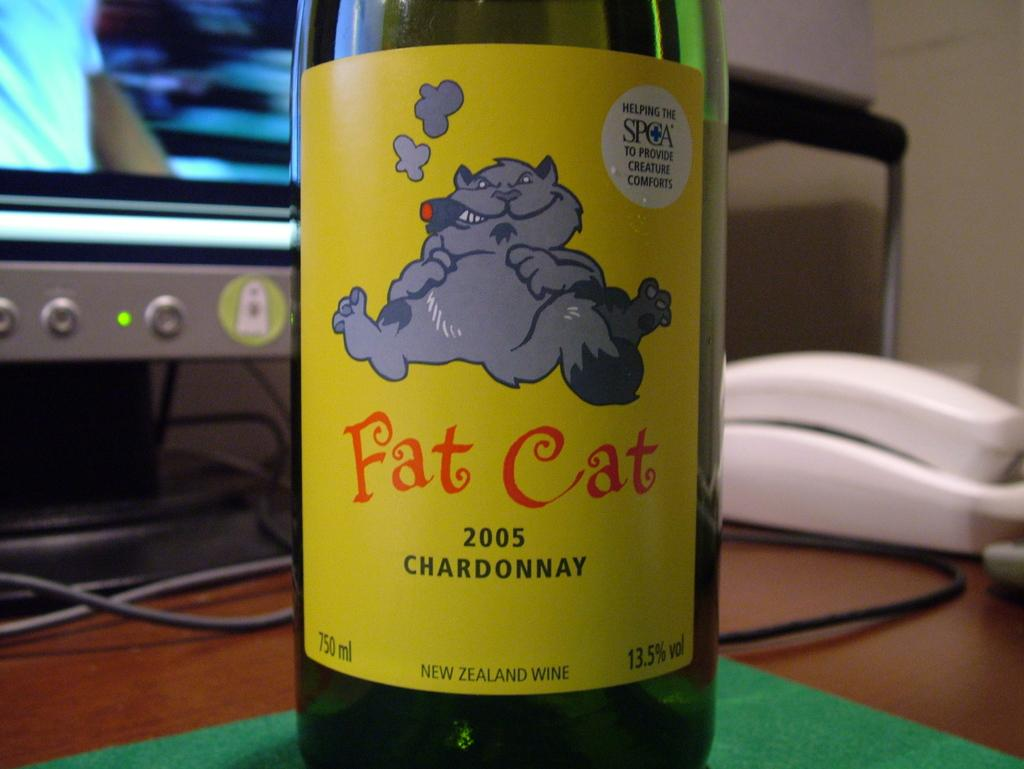<image>
Provide a brief description of the given image. A bottle of 2005 Fat Cat chardonnay on a desk. 